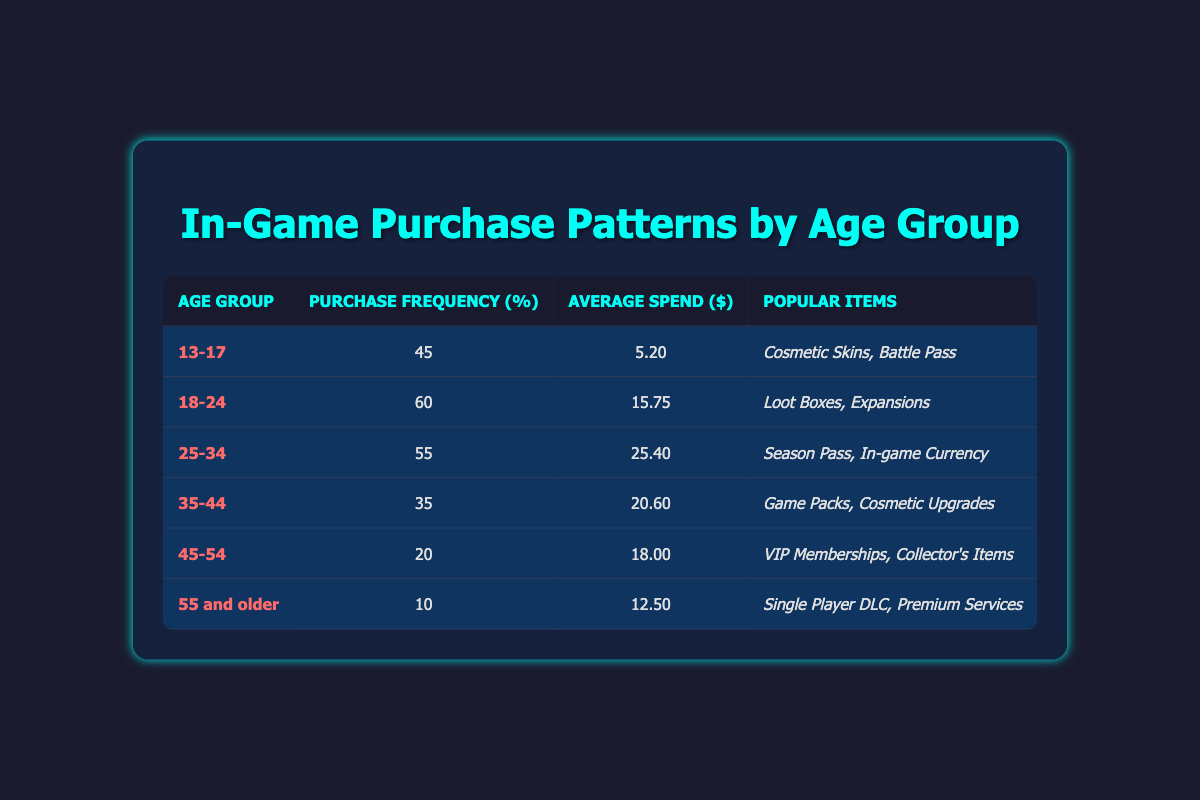What is the purchase frequency for the age group 25-34? The table indicates that the purchase frequency for the age group 25-34 is provided directly in the table under the corresponding row, which shows a value of 55.
Answer: 55 Which age group has the highest average spend? By comparing the average spend values across all the age groups listed in the table, it is clear that the age group 25-34 has the highest average spend of 25.40.
Answer: 25.40 What is the total purchase frequency of players aged 45 and older? The total purchase frequency for players aged 45 and older can be calculated by summing the purchase frequencies of the age groups 45-54 (20) and 55 and older (10). This gives a total of 20 + 10 = 30.
Answer: 30 Is it true that players aged 35-44 spend more on average than those aged 18-24? Comparing the average spend values, players aged 35-44 have an average spend of 20.60 while those aged 18-24 spend an average of 15.75. Therefore, it is true that players aged 35-44 spend more on average.
Answer: Yes What is the difference in purchase frequency between the age groups 18-24 and 35-44? The purchase frequency for the age group 18-24 is 60, while for 35-44 it is 35. The difference can be calculated as 60 - 35 = 25.
Answer: 25 Which items are popular among players aged 13-17? For the age group 13-17, the table lists "Cosmetic Skins" and "Battle Pass" as the popular items. This information is directly pulled from the corresponding row in the table.
Answer: Cosmetic Skins, Battle Pass What is the average spend of players aged 45-54? From the table, we can see that the average spend for the age group 45-54 is directly stated as 18.00.
Answer: 18.00 Are players aged 55 and older more likely to purchase than those aged 45-54? From the table, the purchase frequency for players aged 55 and older is 10, whereas for the 45-54 age group it is 20. Thus, players aged 55 and older are less likely to purchase.
Answer: No 